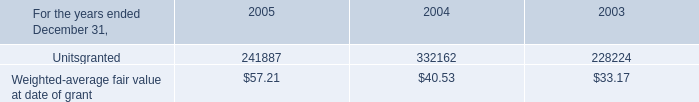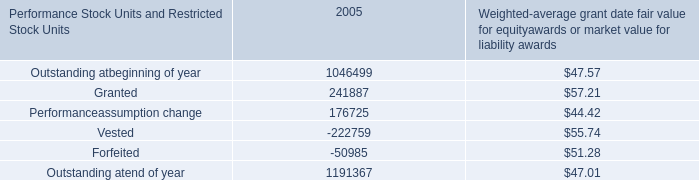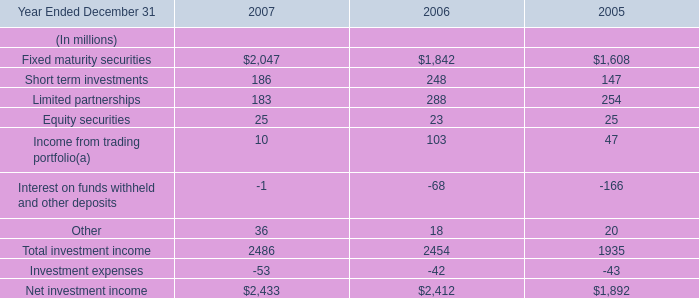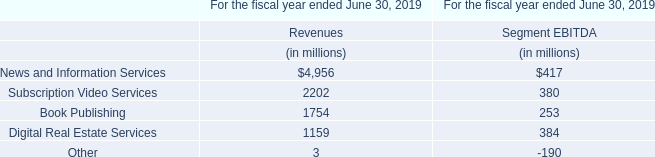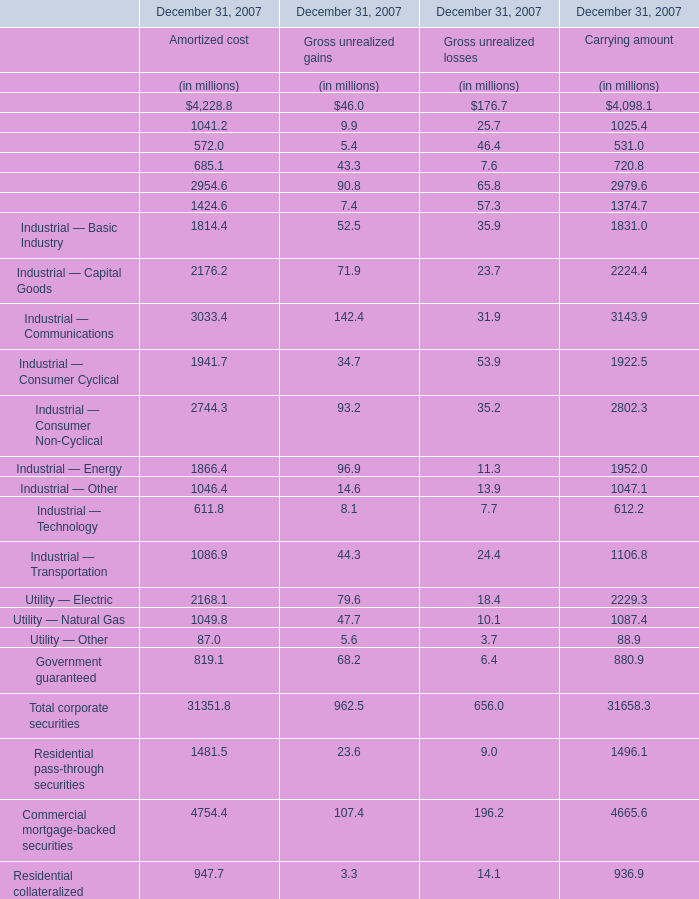What was the average of Utility — Electric for Amortized cost, Gross unrealized gains, and Gross unrealized losses? (in million) 
Computations: (((2168.1 + 79.6) + 18.4) / 3)
Answer: 755.36667. 